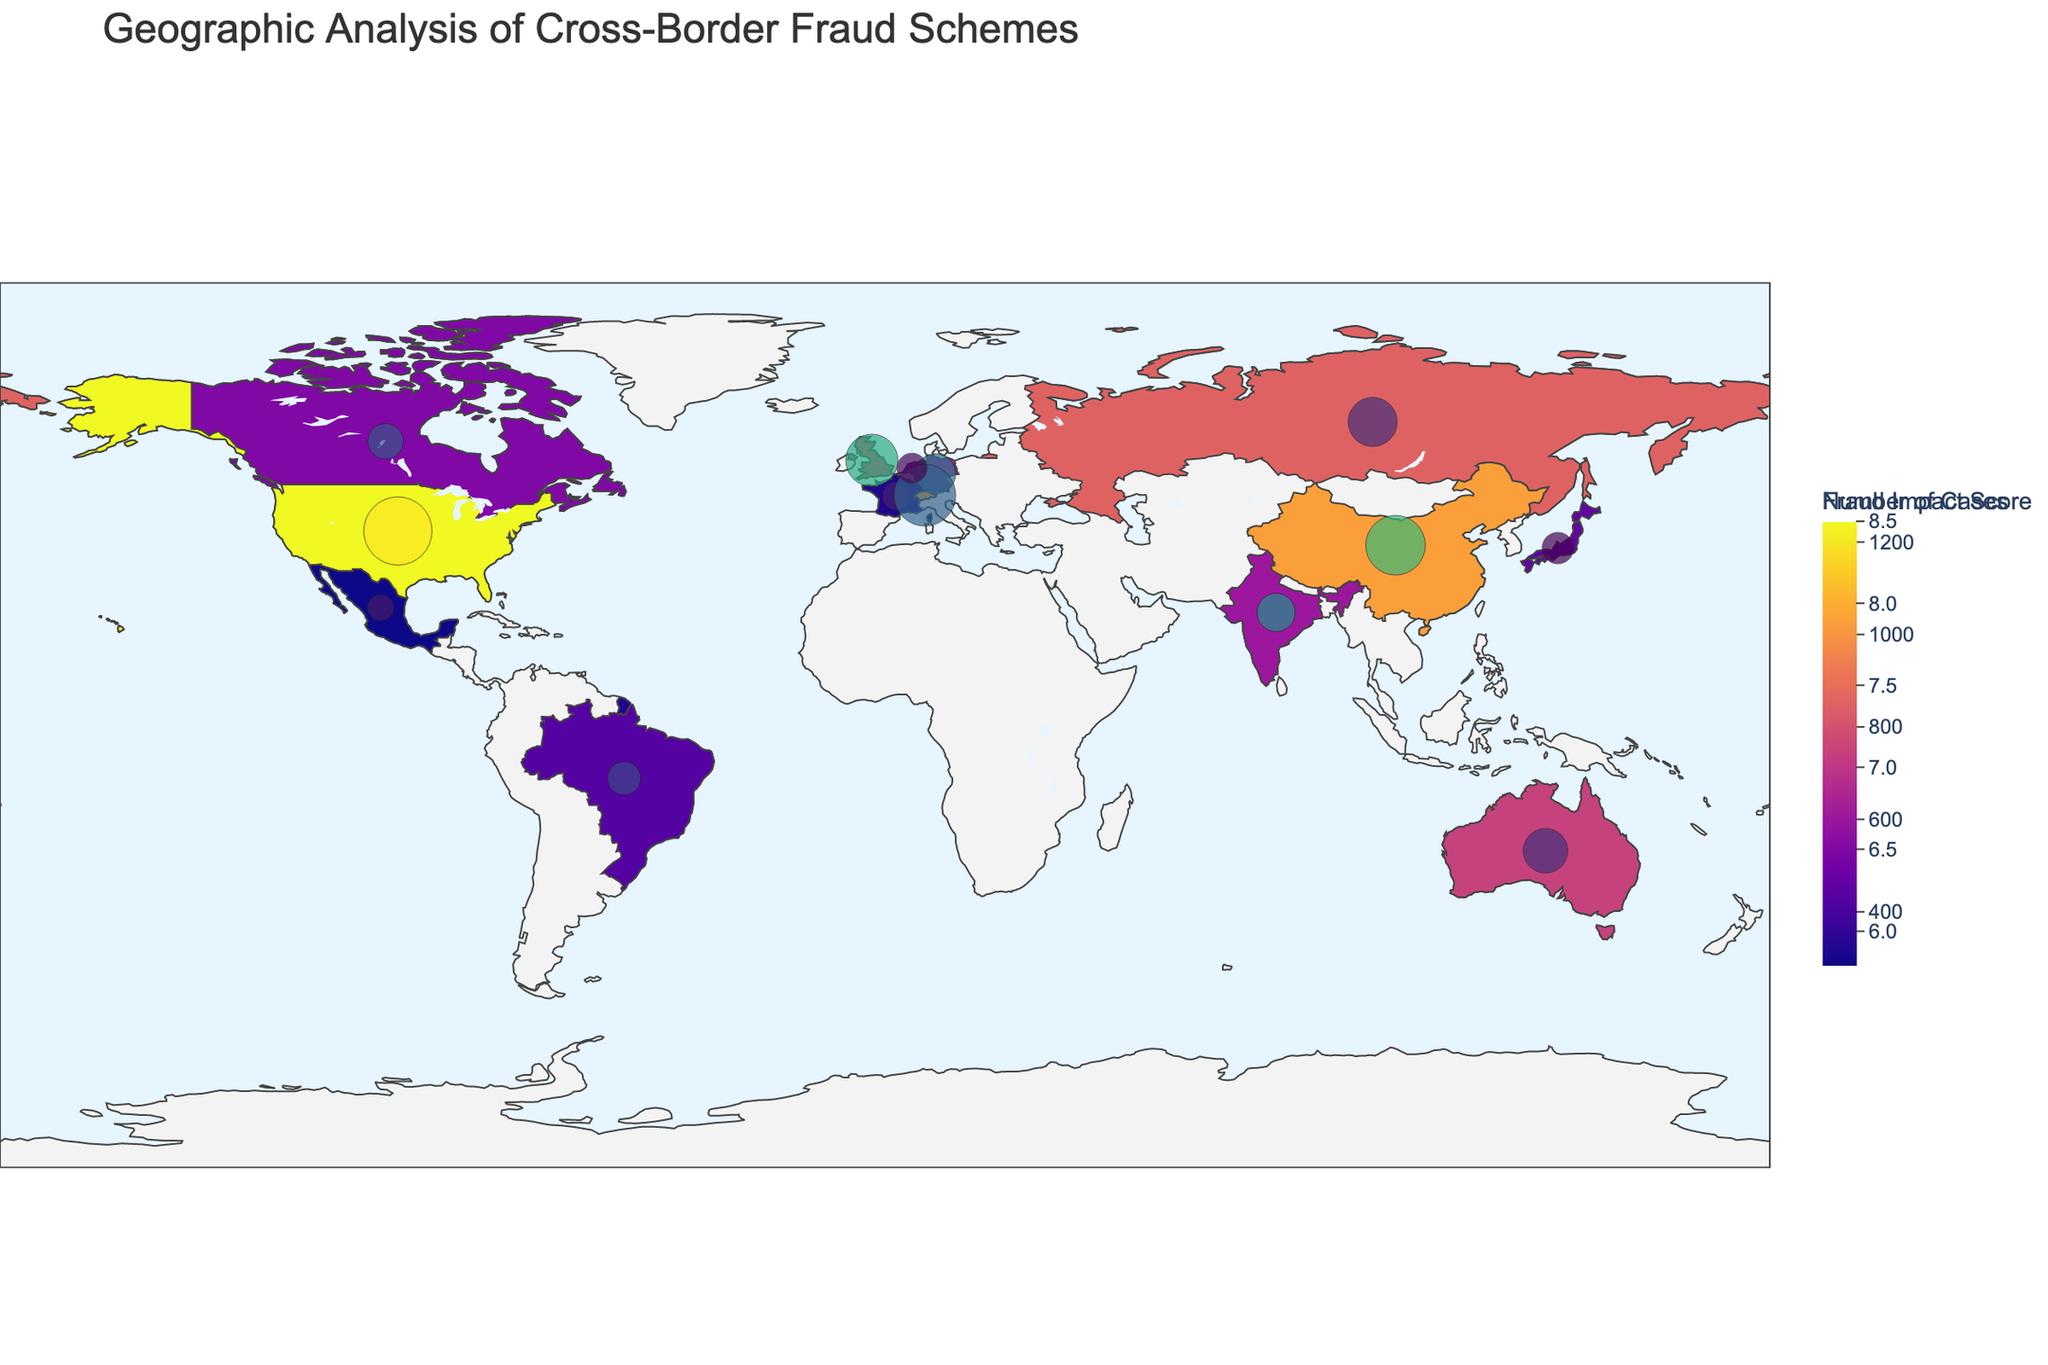What is the title of the figure? The title of the figure is typically found at the top and provides an overview of the subject matter being displayed. In this case, it indicates the geographic analysis of cross-border fraud schemes.
Answer: Geographic Analysis of Cross-Border Fraud Schemes Which country has the highest impact score for fraud schemes? To determine this, find the country with the darkest color shaded on the choropleth map, as the color intensity represents the impact score.
Answer: United States What type of fraud scheme is most prevalent in China according to the figure? Hover over or locate China on the map. The hover text or the description will indicate the specific fraud scheme associated with China.
Answer: Trade-Based Money Laundering How many cases of wire transfer fraud are reported in the United States? Hovering over the United States will show details such as the type of fraud, number of cases, and other relevant information. Note the number of cases.
Answer: 1245 Which country has the largest financial loss due to fraud schemes as indicated by the size of the bubble? The size of the bubble on the figure represents the financial loss. Identify the country associated with the largest bubble.
Answer: United States What’s the combined financial loss for Switzerland and Brazil? Find the financial losses for Switzerland and Brazil from the hover text or bubble sizes and sum them up: $730M (Switzerland) + $210M (Brazil).
Answer: 940 million USD Compare the impact scores of the United Kingdom and Russia. Which country has a higher score? Hovering over both the United Kingdom and Russia will reveal their impact scores. Compare the scores directly.
Answer: United Kingdom (7.2) has a lower score than Russia (7.4) Which country experiences identity theft as the main fraud scheme and what is the impact score? Hover over Canada on the map to see the type of fraud scheme and impact score associated with it.
Answer: Canada, 6.5 What is the average number of fraud cases in India and Japan? Hovering over India and Japan will reveal the number of fraud cases in each country. Find the average by summing up the cases and dividing by 2: (765 + 287) / 2 = 526.
Answer: 526 Which country has fewer cases of fraud: Australia or Netherlands? Hover over Australia and Netherlands to find the number of fraud cases, then compare the values.
Answer: Netherlands (298) 